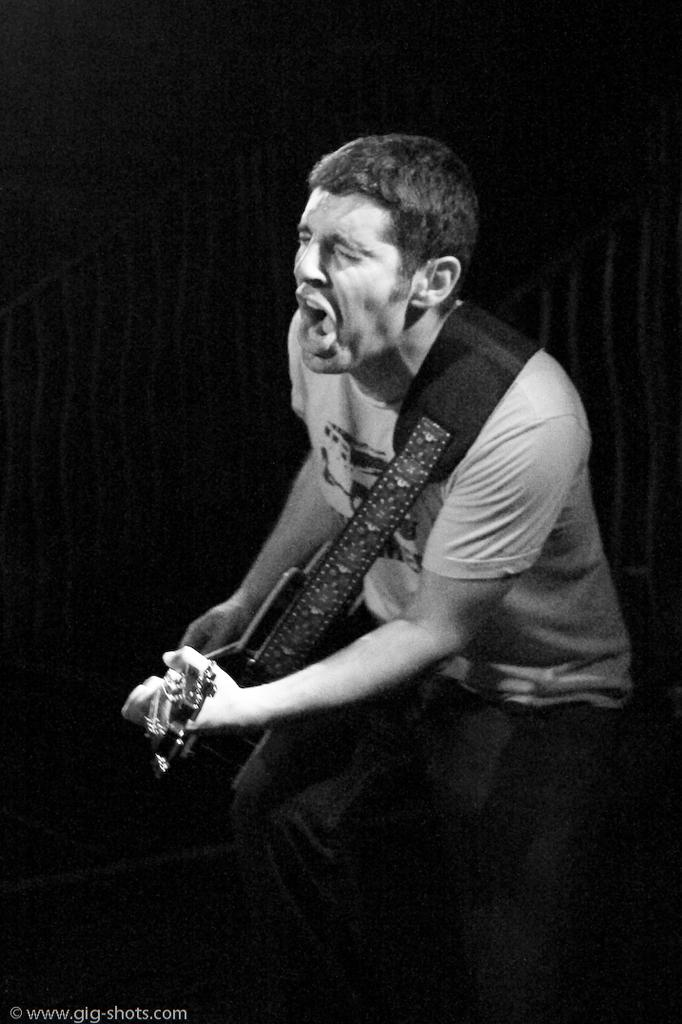What is the main subject of the image? There is a man in the center of the image. What is the man doing in the image? The man is playing a guitar and appears to be singing. What type of ear is visible on the flag in the image? There is no flag or ear present in the image; it features a man playing a guitar and singing. 